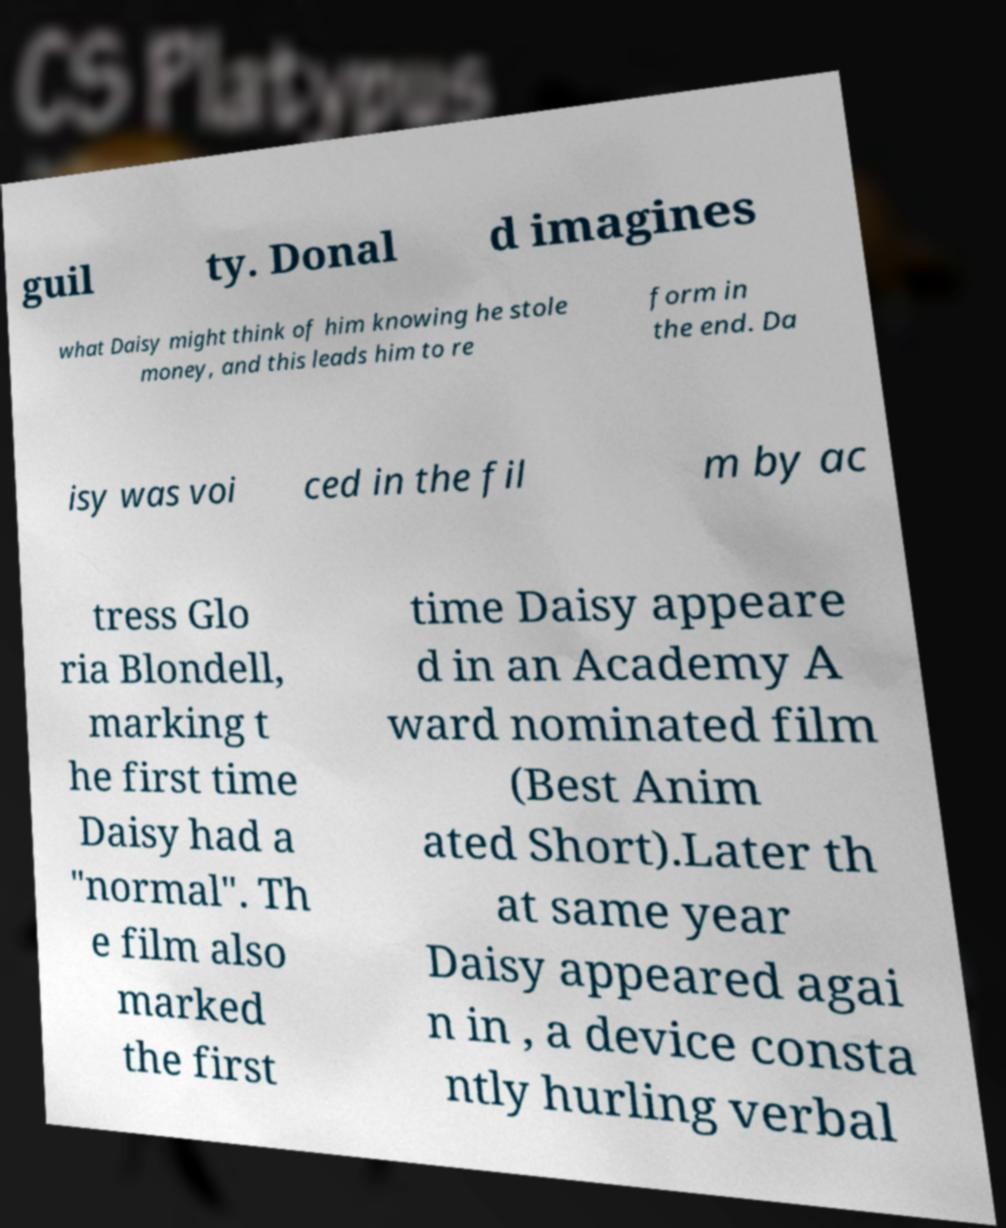Please read and relay the text visible in this image. What does it say? guil ty. Donal d imagines what Daisy might think of him knowing he stole money, and this leads him to re form in the end. Da isy was voi ced in the fil m by ac tress Glo ria Blondell, marking t he first time Daisy had a "normal". Th e film also marked the first time Daisy appeare d in an Academy A ward nominated film (Best Anim ated Short).Later th at same year Daisy appeared agai n in , a device consta ntly hurling verbal 